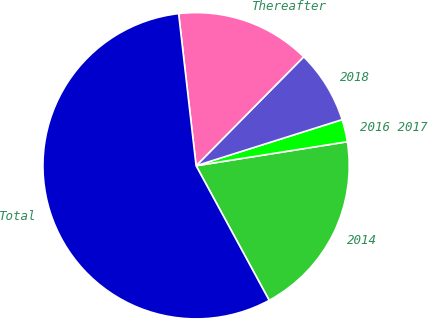Convert chart to OTSL. <chart><loc_0><loc_0><loc_500><loc_500><pie_chart><fcel>2014<fcel>2016 2017<fcel>2018<fcel>Thereafter<fcel>Total<nl><fcel>19.59%<fcel>2.36%<fcel>7.73%<fcel>14.22%<fcel>56.09%<nl></chart> 